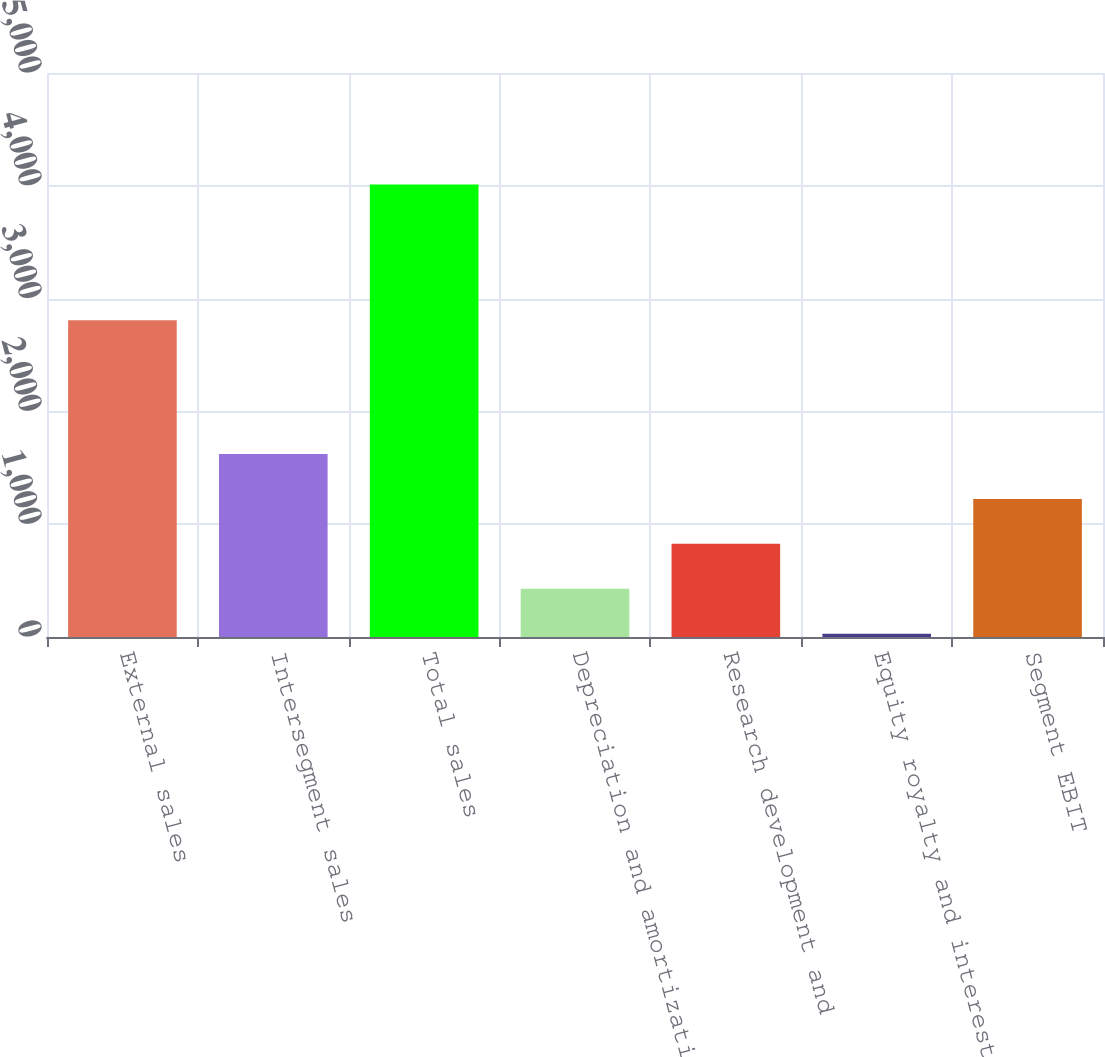Convert chart. <chart><loc_0><loc_0><loc_500><loc_500><bar_chart><fcel>External sales<fcel>Intersegment sales<fcel>Total sales<fcel>Depreciation and amortization<fcel>Research development and<fcel>Equity royalty and interest<fcel>Segment EBIT<nl><fcel>2809<fcel>1622.2<fcel>4012<fcel>427.3<fcel>825.6<fcel>29<fcel>1223.9<nl></chart> 